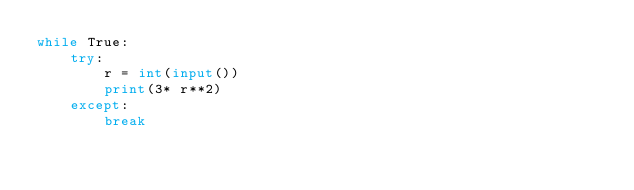Convert code to text. <code><loc_0><loc_0><loc_500><loc_500><_Python_>while True:
    try:
        r = int(input())
        print(3* r**2)
    except:
        break</code> 